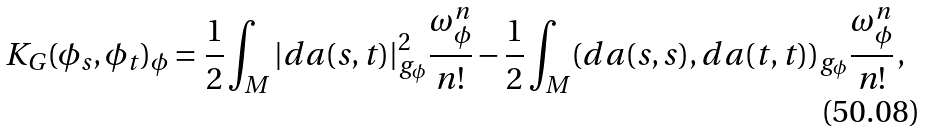<formula> <loc_0><loc_0><loc_500><loc_500>K _ { G } ( \phi _ { s } , \phi _ { t } ) _ { \phi } = \frac { 1 } { 2 } \int _ { M } | d a ( s , t ) | _ { g _ { \phi } } ^ { 2 } \frac { \omega _ { \phi } ^ { n } } { n ! } - \frac { 1 } { 2 } \int _ { M } ( d a ( s , s ) , d a ( t , t ) ) _ { g _ { \phi } } \frac { \omega _ { \phi } ^ { n } } { n ! } \, ,</formula> 